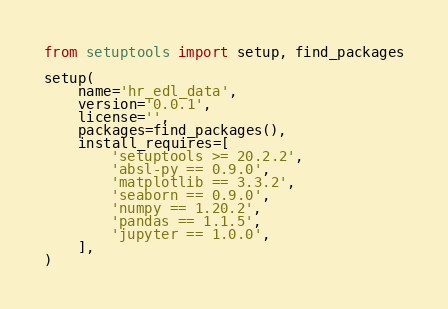Convert code to text. <code><loc_0><loc_0><loc_500><loc_500><_Python_>from setuptools import setup, find_packages

setup(
    name='hr_edl_data',
    version='0.0.1',
    license='',
    packages=find_packages(),
    install_requires=[
        'setuptools >= 20.2.2',
        'absl-py == 0.9.0',
        'matplotlib == 3.3.2',
        'seaborn == 0.9.0',
        'numpy == 1.20.2',
        'pandas == 1.1.5',
        'jupyter == 1.0.0',
    ],
)
</code> 